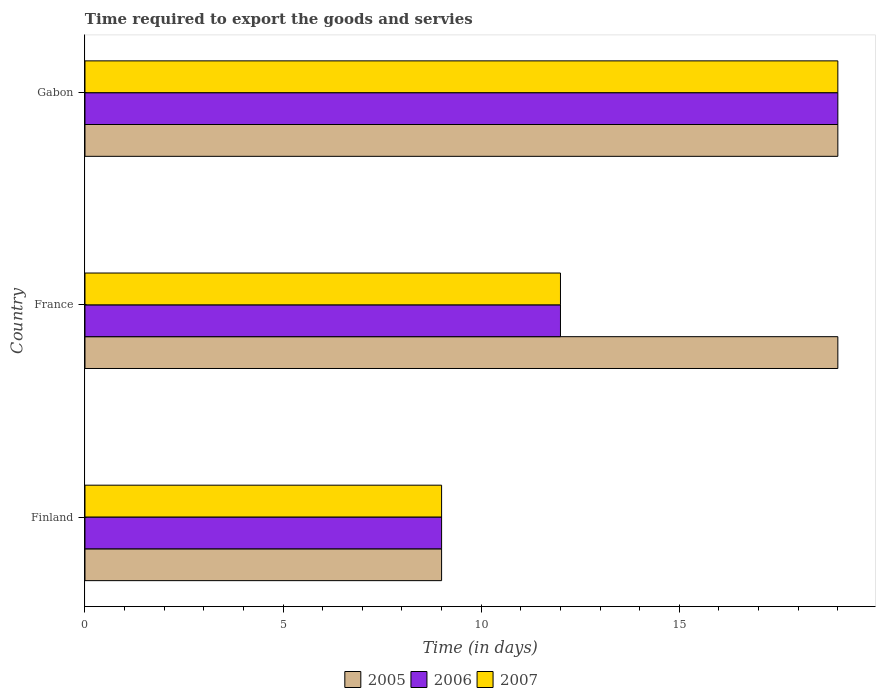How many different coloured bars are there?
Provide a short and direct response. 3. How many groups of bars are there?
Offer a terse response. 3. Are the number of bars per tick equal to the number of legend labels?
Your answer should be very brief. Yes. How many bars are there on the 2nd tick from the top?
Provide a short and direct response. 3. In how many cases, is the number of bars for a given country not equal to the number of legend labels?
Your answer should be very brief. 0. In which country was the number of days required to export the goods and services in 2005 maximum?
Your answer should be very brief. France. What is the difference between the number of days required to export the goods and services in 2005 in France and that in Gabon?
Make the answer very short. 0. What is the average number of days required to export the goods and services in 2007 per country?
Provide a short and direct response. 13.33. What is the difference between the number of days required to export the goods and services in 2007 and number of days required to export the goods and services in 2005 in France?
Provide a succinct answer. -7. In how many countries, is the number of days required to export the goods and services in 2007 greater than 16 days?
Offer a terse response. 1. What is the ratio of the number of days required to export the goods and services in 2006 in France to that in Gabon?
Offer a terse response. 0.63. Is the number of days required to export the goods and services in 2007 in Finland less than that in Gabon?
Offer a very short reply. Yes. What is the difference between the highest and the second highest number of days required to export the goods and services in 2005?
Keep it short and to the point. 0. What is the difference between the highest and the lowest number of days required to export the goods and services in 2007?
Ensure brevity in your answer.  10. In how many countries, is the number of days required to export the goods and services in 2006 greater than the average number of days required to export the goods and services in 2006 taken over all countries?
Offer a very short reply. 1. What does the 3rd bar from the top in France represents?
Your response must be concise. 2005. How many bars are there?
Keep it short and to the point. 9. Are all the bars in the graph horizontal?
Provide a succinct answer. Yes. Are the values on the major ticks of X-axis written in scientific E-notation?
Provide a succinct answer. No. Does the graph contain grids?
Your answer should be compact. No. What is the title of the graph?
Your response must be concise. Time required to export the goods and servies. Does "2005" appear as one of the legend labels in the graph?
Ensure brevity in your answer.  Yes. What is the label or title of the X-axis?
Make the answer very short. Time (in days). What is the label or title of the Y-axis?
Your answer should be compact. Country. What is the Time (in days) of 2005 in Finland?
Provide a succinct answer. 9. What is the Time (in days) of 2006 in France?
Your answer should be very brief. 12. What is the Time (in days) in 2005 in Gabon?
Give a very brief answer. 19. Across all countries, what is the maximum Time (in days) in 2006?
Offer a terse response. 19. Across all countries, what is the maximum Time (in days) of 2007?
Your response must be concise. 19. Across all countries, what is the minimum Time (in days) in 2005?
Keep it short and to the point. 9. Across all countries, what is the minimum Time (in days) in 2006?
Your answer should be compact. 9. What is the total Time (in days) of 2005 in the graph?
Provide a short and direct response. 47. What is the total Time (in days) of 2006 in the graph?
Provide a succinct answer. 40. What is the total Time (in days) of 2007 in the graph?
Provide a short and direct response. 40. What is the difference between the Time (in days) of 2005 in Finland and that in Gabon?
Your answer should be compact. -10. What is the difference between the Time (in days) of 2006 in Finland and that in Gabon?
Make the answer very short. -10. What is the difference between the Time (in days) of 2007 in Finland and that in Gabon?
Give a very brief answer. -10. What is the difference between the Time (in days) of 2005 in France and that in Gabon?
Keep it short and to the point. 0. What is the difference between the Time (in days) of 2007 in France and that in Gabon?
Provide a short and direct response. -7. What is the difference between the Time (in days) in 2005 in Finland and the Time (in days) in 2006 in Gabon?
Offer a very short reply. -10. What is the average Time (in days) of 2005 per country?
Provide a short and direct response. 15.67. What is the average Time (in days) of 2006 per country?
Your response must be concise. 13.33. What is the average Time (in days) of 2007 per country?
Provide a succinct answer. 13.33. What is the difference between the Time (in days) in 2005 and Time (in days) in 2006 in Finland?
Your answer should be very brief. 0. What is the difference between the Time (in days) of 2005 and Time (in days) of 2007 in Finland?
Your answer should be compact. 0. What is the difference between the Time (in days) in 2005 and Time (in days) in 2007 in France?
Provide a short and direct response. 7. What is the difference between the Time (in days) in 2005 and Time (in days) in 2007 in Gabon?
Your answer should be compact. 0. What is the ratio of the Time (in days) of 2005 in Finland to that in France?
Your response must be concise. 0.47. What is the ratio of the Time (in days) of 2007 in Finland to that in France?
Ensure brevity in your answer.  0.75. What is the ratio of the Time (in days) of 2005 in Finland to that in Gabon?
Offer a very short reply. 0.47. What is the ratio of the Time (in days) of 2006 in Finland to that in Gabon?
Ensure brevity in your answer.  0.47. What is the ratio of the Time (in days) of 2007 in Finland to that in Gabon?
Provide a short and direct response. 0.47. What is the ratio of the Time (in days) of 2006 in France to that in Gabon?
Provide a succinct answer. 0.63. What is the ratio of the Time (in days) in 2007 in France to that in Gabon?
Make the answer very short. 0.63. What is the difference between the highest and the second highest Time (in days) in 2005?
Your response must be concise. 0. What is the difference between the highest and the second highest Time (in days) in 2006?
Provide a short and direct response. 7. What is the difference between the highest and the lowest Time (in days) in 2005?
Offer a very short reply. 10. What is the difference between the highest and the lowest Time (in days) in 2007?
Give a very brief answer. 10. 